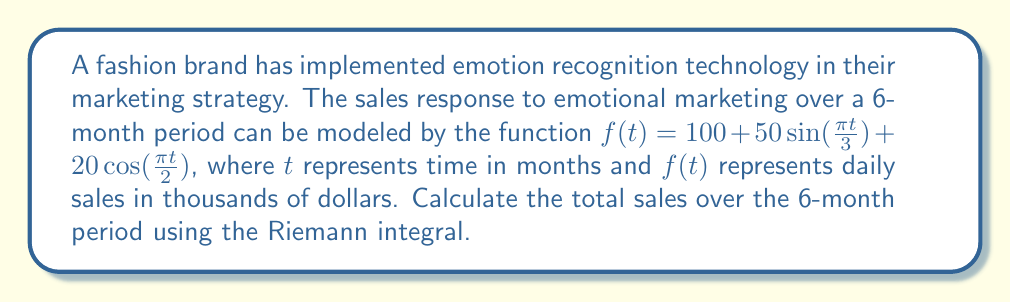Show me your answer to this math problem. To solve this problem, we need to calculate the Riemann integral of the given function over the interval [0, 6]. The steps are as follows:

1) The Riemann integral is given by:

   $$\int_0^6 f(t) dt = \int_0^6 (100 + 50\sin(\frac{\pi t}{3}) + 20\cos(\frac{\pi t}{2})) dt$$

2) We can integrate each term separately:

   a) $\int_0^6 100 dt = 100t \big|_0^6 = 600$

   b) $\int_0^6 50\sin(\frac{\pi t}{3}) dt = -\frac{150}{\pi} \cos(\frac{\pi t}{3}) \big|_0^6 = -\frac{150}{\pi} (\cos(2\pi) - \cos(0)) = 0$

   c) $\int_0^6 20\cos(\frac{\pi t}{2}) dt = \frac{40}{\pi} \sin(\frac{\pi t}{2}) \big|_0^6 = \frac{40}{\pi} (\sin(3\pi) - \sin(0)) = 0$

3) Adding these results:

   $$\int_0^6 f(t) dt = 600 + 0 + 0 = 600$$

4) This result represents the total sales in thousands of dollars over the 6-month period.

5) To get the total sales in dollars, we multiply by 1000:

   Total sales = 600 * 1000 = 600,000 dollars
Answer: $600,000 